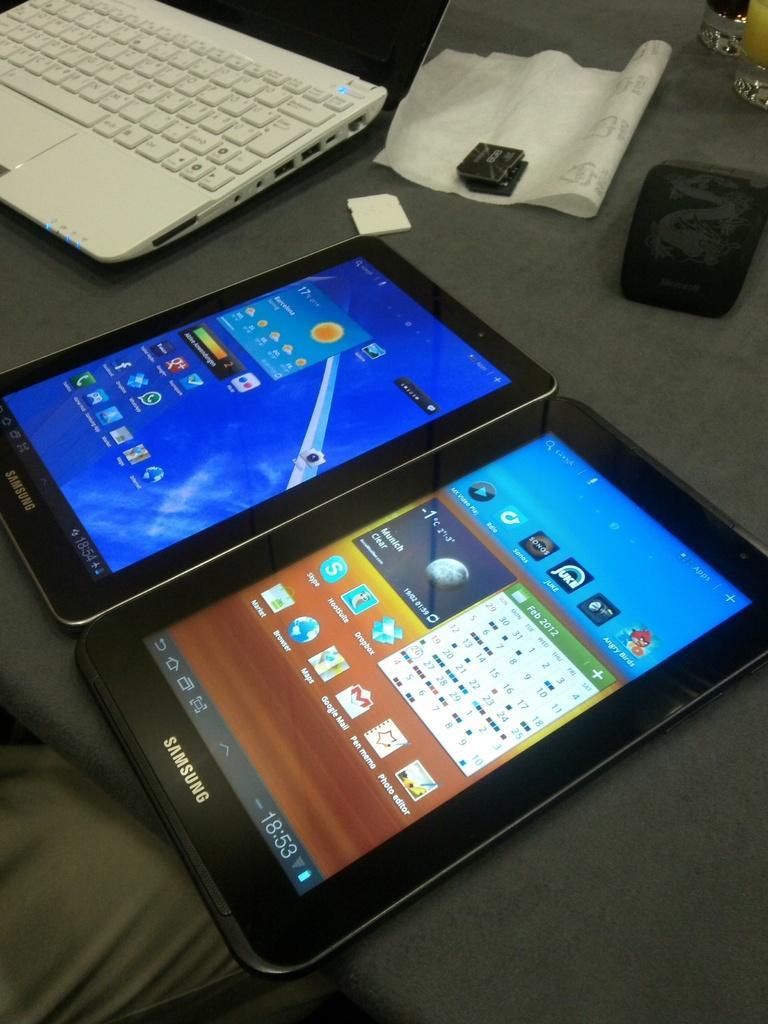Can you describe this image briefly? In this picture we can see the tablets, laptop, glasses of drinks and some items are placed on the top of the table and we can see the icons, text and numbers on the displays of the tablets. In the left corner we can see a person like thing. 